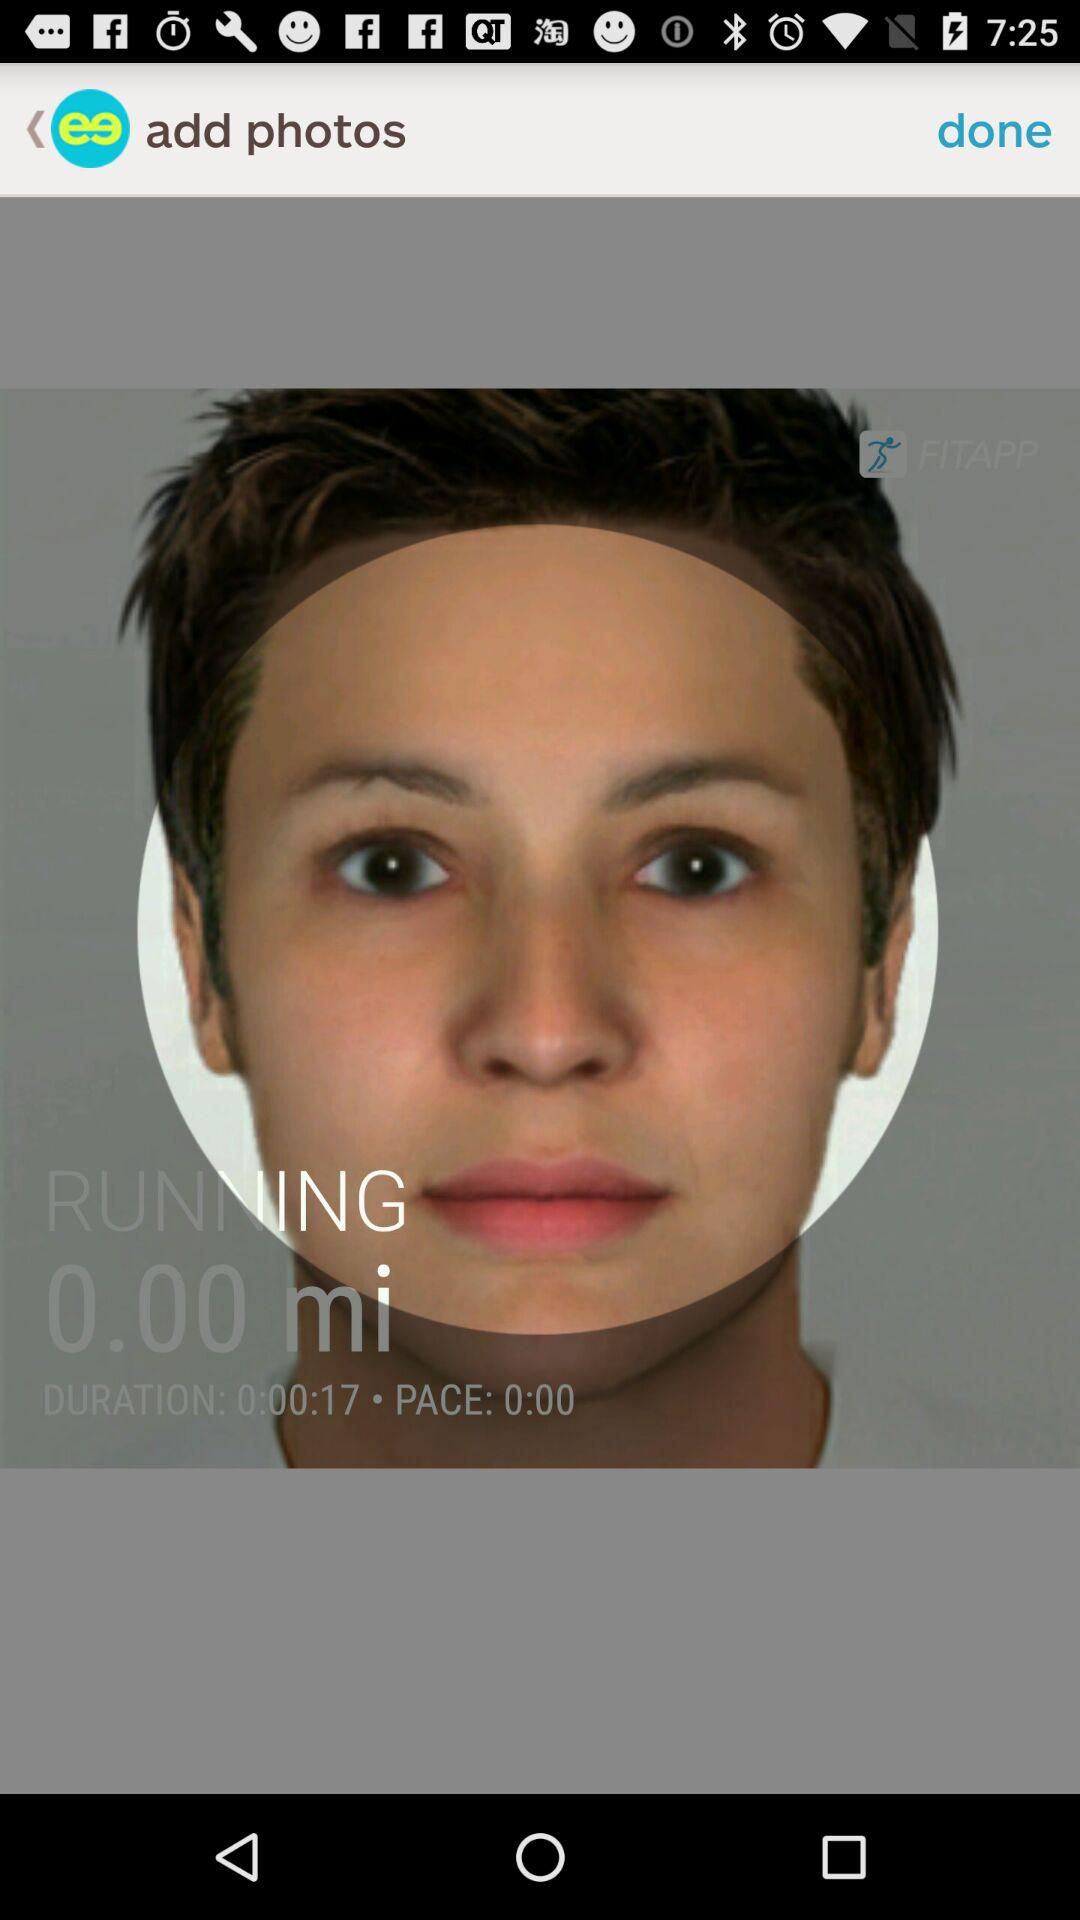What is the "PACE"? The "PACE" is 0:00. 